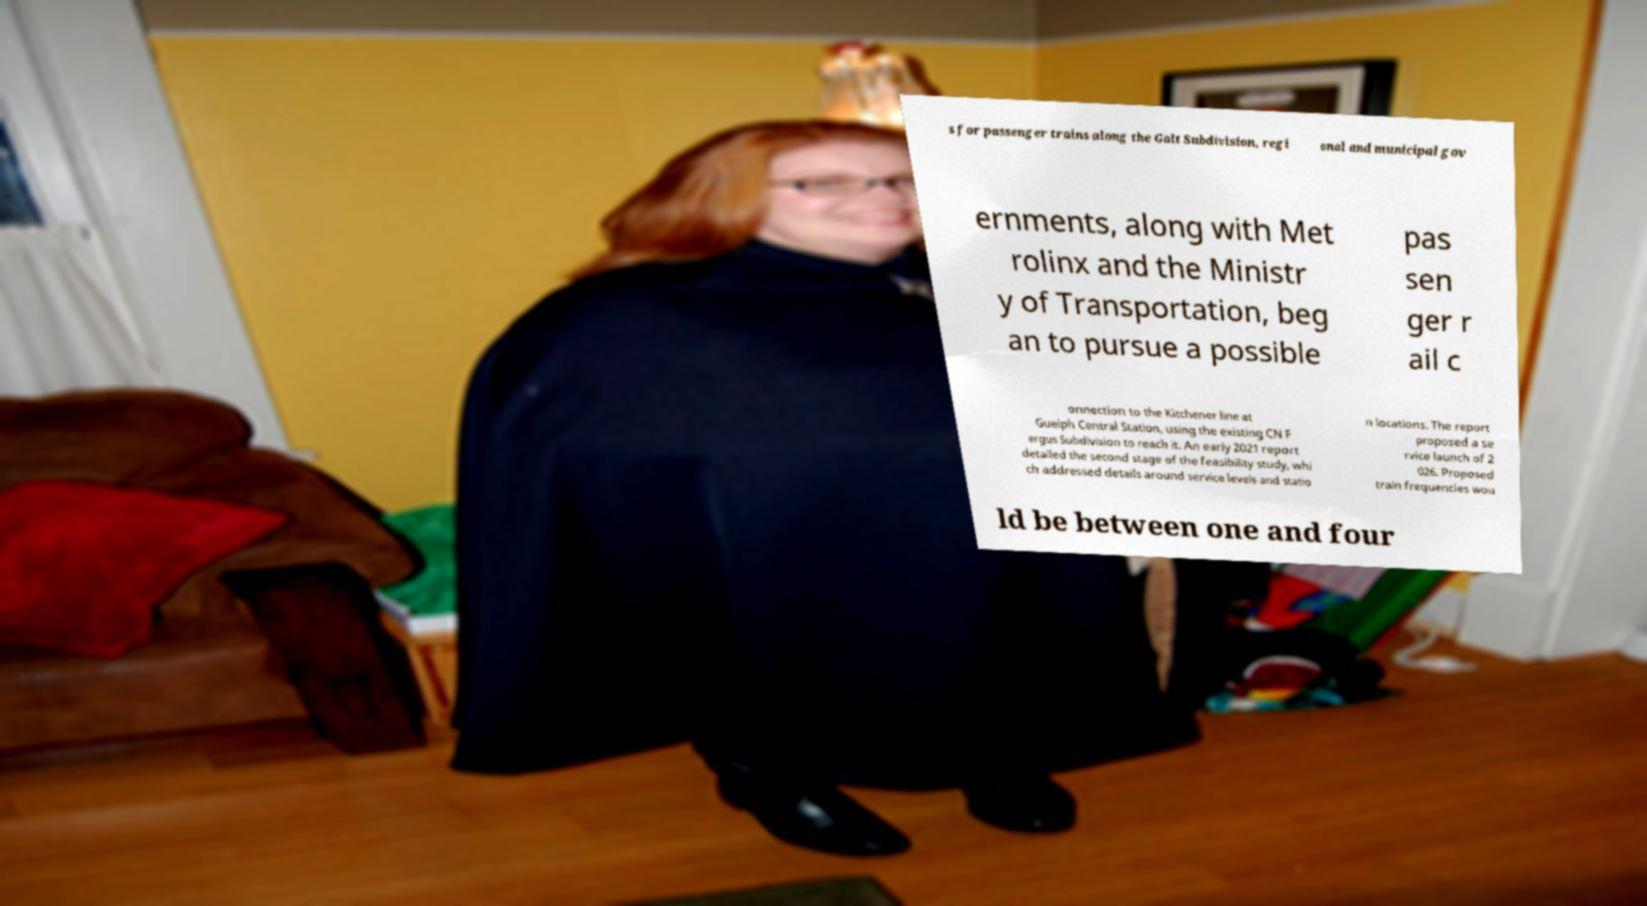Can you accurately transcribe the text from the provided image for me? s for passenger trains along the Galt Subdivision, regi onal and municipal gov ernments, along with Met rolinx and the Ministr y of Transportation, beg an to pursue a possible pas sen ger r ail c onnection to the Kitchener line at Guelph Central Station, using the existing CN F ergus Subdivision to reach it. An early 2021 report detailed the second stage of the feasibility study, whi ch addressed details around service levels and statio n locations. The report proposed a se rvice launch of 2 026. Proposed train frequencies wou ld be between one and four 